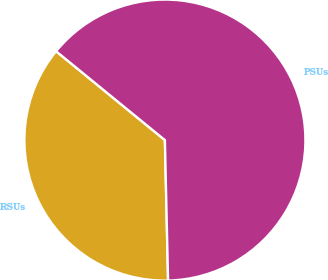Convert chart. <chart><loc_0><loc_0><loc_500><loc_500><pie_chart><fcel>RSUs<fcel>PSUs<nl><fcel>36.26%<fcel>63.74%<nl></chart> 